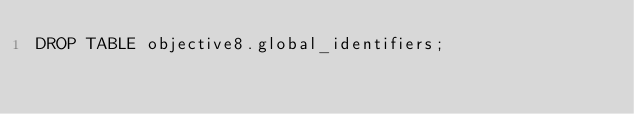<code> <loc_0><loc_0><loc_500><loc_500><_SQL_>DROP TABLE objective8.global_identifiers;
</code> 